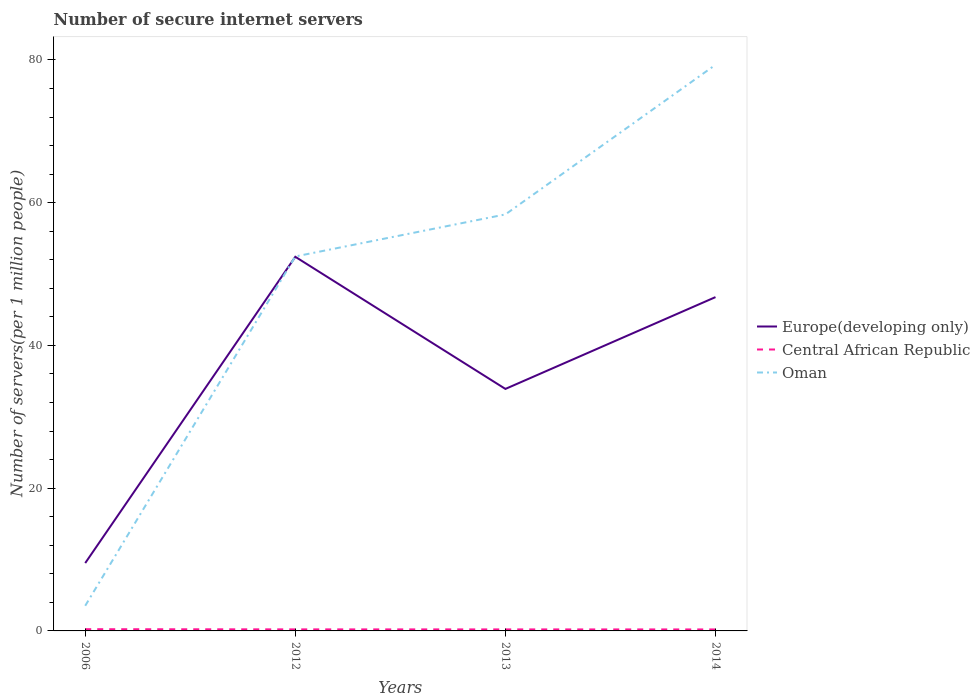How many different coloured lines are there?
Ensure brevity in your answer.  3. Across all years, what is the maximum number of secure internet servers in Central African Republic?
Offer a terse response. 0.21. What is the total number of secure internet servers in Central African Republic in the graph?
Keep it short and to the point. 0. What is the difference between the highest and the second highest number of secure internet servers in Europe(developing only)?
Your response must be concise. 42.91. What is the difference between the highest and the lowest number of secure internet servers in Europe(developing only)?
Keep it short and to the point. 2. Is the number of secure internet servers in Central African Republic strictly greater than the number of secure internet servers in Oman over the years?
Make the answer very short. Yes. How many lines are there?
Keep it short and to the point. 3. What is the difference between two consecutive major ticks on the Y-axis?
Ensure brevity in your answer.  20. Does the graph contain grids?
Make the answer very short. No. How many legend labels are there?
Offer a very short reply. 3. How are the legend labels stacked?
Keep it short and to the point. Vertical. What is the title of the graph?
Give a very brief answer. Number of secure internet servers. What is the label or title of the X-axis?
Offer a terse response. Years. What is the label or title of the Y-axis?
Your answer should be compact. Number of servers(per 1 million people). What is the Number of servers(per 1 million people) in Europe(developing only) in 2006?
Give a very brief answer. 9.51. What is the Number of servers(per 1 million people) of Central African Republic in 2006?
Provide a succinct answer. 0.24. What is the Number of servers(per 1 million people) in Oman in 2006?
Offer a very short reply. 3.52. What is the Number of servers(per 1 million people) in Europe(developing only) in 2012?
Keep it short and to the point. 52.42. What is the Number of servers(per 1 million people) in Central African Republic in 2012?
Offer a very short reply. 0.22. What is the Number of servers(per 1 million people) of Oman in 2012?
Your response must be concise. 52.47. What is the Number of servers(per 1 million people) of Europe(developing only) in 2013?
Offer a very short reply. 33.91. What is the Number of servers(per 1 million people) in Central African Republic in 2013?
Keep it short and to the point. 0.21. What is the Number of servers(per 1 million people) in Oman in 2013?
Keep it short and to the point. 58.36. What is the Number of servers(per 1 million people) in Europe(developing only) in 2014?
Offer a terse response. 46.77. What is the Number of servers(per 1 million people) of Central African Republic in 2014?
Your response must be concise. 0.21. What is the Number of servers(per 1 million people) of Oman in 2014?
Provide a short and direct response. 79.32. Across all years, what is the maximum Number of servers(per 1 million people) of Europe(developing only)?
Ensure brevity in your answer.  52.42. Across all years, what is the maximum Number of servers(per 1 million people) of Central African Republic?
Give a very brief answer. 0.24. Across all years, what is the maximum Number of servers(per 1 million people) of Oman?
Give a very brief answer. 79.32. Across all years, what is the minimum Number of servers(per 1 million people) of Europe(developing only)?
Offer a very short reply. 9.51. Across all years, what is the minimum Number of servers(per 1 million people) of Central African Republic?
Offer a terse response. 0.21. Across all years, what is the minimum Number of servers(per 1 million people) in Oman?
Make the answer very short. 3.52. What is the total Number of servers(per 1 million people) in Europe(developing only) in the graph?
Provide a short and direct response. 142.6. What is the total Number of servers(per 1 million people) in Central African Republic in the graph?
Offer a terse response. 0.88. What is the total Number of servers(per 1 million people) in Oman in the graph?
Make the answer very short. 193.67. What is the difference between the Number of servers(per 1 million people) of Europe(developing only) in 2006 and that in 2012?
Your answer should be very brief. -42.91. What is the difference between the Number of servers(per 1 million people) of Central African Republic in 2006 and that in 2012?
Offer a terse response. 0.03. What is the difference between the Number of servers(per 1 million people) in Oman in 2006 and that in 2012?
Offer a very short reply. -48.94. What is the difference between the Number of servers(per 1 million people) of Europe(developing only) in 2006 and that in 2013?
Your answer should be very brief. -24.4. What is the difference between the Number of servers(per 1 million people) in Oman in 2006 and that in 2013?
Give a very brief answer. -54.83. What is the difference between the Number of servers(per 1 million people) in Europe(developing only) in 2006 and that in 2014?
Provide a succinct answer. -37.26. What is the difference between the Number of servers(per 1 million people) in Central African Republic in 2006 and that in 2014?
Offer a terse response. 0.03. What is the difference between the Number of servers(per 1 million people) in Oman in 2006 and that in 2014?
Offer a very short reply. -75.79. What is the difference between the Number of servers(per 1 million people) of Europe(developing only) in 2012 and that in 2013?
Keep it short and to the point. 18.51. What is the difference between the Number of servers(per 1 million people) in Central African Republic in 2012 and that in 2013?
Keep it short and to the point. 0. What is the difference between the Number of servers(per 1 million people) of Oman in 2012 and that in 2013?
Provide a short and direct response. -5.89. What is the difference between the Number of servers(per 1 million people) of Europe(developing only) in 2012 and that in 2014?
Offer a very short reply. 5.65. What is the difference between the Number of servers(per 1 million people) in Central African Republic in 2012 and that in 2014?
Give a very brief answer. 0.01. What is the difference between the Number of servers(per 1 million people) of Oman in 2012 and that in 2014?
Offer a terse response. -26.85. What is the difference between the Number of servers(per 1 million people) of Europe(developing only) in 2013 and that in 2014?
Your response must be concise. -12.86. What is the difference between the Number of servers(per 1 million people) in Central African Republic in 2013 and that in 2014?
Ensure brevity in your answer.  0. What is the difference between the Number of servers(per 1 million people) in Oman in 2013 and that in 2014?
Ensure brevity in your answer.  -20.96. What is the difference between the Number of servers(per 1 million people) of Europe(developing only) in 2006 and the Number of servers(per 1 million people) of Central African Republic in 2012?
Ensure brevity in your answer.  9.29. What is the difference between the Number of servers(per 1 million people) of Europe(developing only) in 2006 and the Number of servers(per 1 million people) of Oman in 2012?
Your answer should be very brief. -42.96. What is the difference between the Number of servers(per 1 million people) of Central African Republic in 2006 and the Number of servers(per 1 million people) of Oman in 2012?
Make the answer very short. -52.22. What is the difference between the Number of servers(per 1 million people) of Europe(developing only) in 2006 and the Number of servers(per 1 million people) of Central African Republic in 2013?
Your answer should be compact. 9.3. What is the difference between the Number of servers(per 1 million people) in Europe(developing only) in 2006 and the Number of servers(per 1 million people) in Oman in 2013?
Ensure brevity in your answer.  -48.85. What is the difference between the Number of servers(per 1 million people) in Central African Republic in 2006 and the Number of servers(per 1 million people) in Oman in 2013?
Offer a terse response. -58.12. What is the difference between the Number of servers(per 1 million people) in Europe(developing only) in 2006 and the Number of servers(per 1 million people) in Central African Republic in 2014?
Give a very brief answer. 9.3. What is the difference between the Number of servers(per 1 million people) of Europe(developing only) in 2006 and the Number of servers(per 1 million people) of Oman in 2014?
Ensure brevity in your answer.  -69.81. What is the difference between the Number of servers(per 1 million people) of Central African Republic in 2006 and the Number of servers(per 1 million people) of Oman in 2014?
Offer a terse response. -79.08. What is the difference between the Number of servers(per 1 million people) of Europe(developing only) in 2012 and the Number of servers(per 1 million people) of Central African Republic in 2013?
Provide a succinct answer. 52.21. What is the difference between the Number of servers(per 1 million people) in Europe(developing only) in 2012 and the Number of servers(per 1 million people) in Oman in 2013?
Your answer should be very brief. -5.94. What is the difference between the Number of servers(per 1 million people) of Central African Republic in 2012 and the Number of servers(per 1 million people) of Oman in 2013?
Ensure brevity in your answer.  -58.14. What is the difference between the Number of servers(per 1 million people) of Europe(developing only) in 2012 and the Number of servers(per 1 million people) of Central African Republic in 2014?
Provide a succinct answer. 52.21. What is the difference between the Number of servers(per 1 million people) in Europe(developing only) in 2012 and the Number of servers(per 1 million people) in Oman in 2014?
Keep it short and to the point. -26.9. What is the difference between the Number of servers(per 1 million people) of Central African Republic in 2012 and the Number of servers(per 1 million people) of Oman in 2014?
Give a very brief answer. -79.1. What is the difference between the Number of servers(per 1 million people) of Europe(developing only) in 2013 and the Number of servers(per 1 million people) of Central African Republic in 2014?
Keep it short and to the point. 33.7. What is the difference between the Number of servers(per 1 million people) in Europe(developing only) in 2013 and the Number of servers(per 1 million people) in Oman in 2014?
Your response must be concise. -45.41. What is the difference between the Number of servers(per 1 million people) in Central African Republic in 2013 and the Number of servers(per 1 million people) in Oman in 2014?
Offer a very short reply. -79.11. What is the average Number of servers(per 1 million people) in Europe(developing only) per year?
Provide a short and direct response. 35.65. What is the average Number of servers(per 1 million people) in Central African Republic per year?
Make the answer very short. 0.22. What is the average Number of servers(per 1 million people) of Oman per year?
Your answer should be very brief. 48.42. In the year 2006, what is the difference between the Number of servers(per 1 million people) in Europe(developing only) and Number of servers(per 1 million people) in Central African Republic?
Your answer should be compact. 9.27. In the year 2006, what is the difference between the Number of servers(per 1 million people) of Europe(developing only) and Number of servers(per 1 million people) of Oman?
Make the answer very short. 5.98. In the year 2006, what is the difference between the Number of servers(per 1 million people) in Central African Republic and Number of servers(per 1 million people) in Oman?
Offer a terse response. -3.28. In the year 2012, what is the difference between the Number of servers(per 1 million people) of Europe(developing only) and Number of servers(per 1 million people) of Central African Republic?
Your answer should be compact. 52.2. In the year 2012, what is the difference between the Number of servers(per 1 million people) of Europe(developing only) and Number of servers(per 1 million people) of Oman?
Keep it short and to the point. -0.05. In the year 2012, what is the difference between the Number of servers(per 1 million people) in Central African Republic and Number of servers(per 1 million people) in Oman?
Your response must be concise. -52.25. In the year 2013, what is the difference between the Number of servers(per 1 million people) of Europe(developing only) and Number of servers(per 1 million people) of Central African Republic?
Give a very brief answer. 33.69. In the year 2013, what is the difference between the Number of servers(per 1 million people) of Europe(developing only) and Number of servers(per 1 million people) of Oman?
Your response must be concise. -24.45. In the year 2013, what is the difference between the Number of servers(per 1 million people) in Central African Republic and Number of servers(per 1 million people) in Oman?
Your answer should be compact. -58.15. In the year 2014, what is the difference between the Number of servers(per 1 million people) in Europe(developing only) and Number of servers(per 1 million people) in Central African Republic?
Your answer should be compact. 46.56. In the year 2014, what is the difference between the Number of servers(per 1 million people) of Europe(developing only) and Number of servers(per 1 million people) of Oman?
Provide a short and direct response. -32.55. In the year 2014, what is the difference between the Number of servers(per 1 million people) of Central African Republic and Number of servers(per 1 million people) of Oman?
Your answer should be very brief. -79.11. What is the ratio of the Number of servers(per 1 million people) in Europe(developing only) in 2006 to that in 2012?
Offer a terse response. 0.18. What is the ratio of the Number of servers(per 1 million people) in Central African Republic in 2006 to that in 2012?
Ensure brevity in your answer.  1.12. What is the ratio of the Number of servers(per 1 million people) in Oman in 2006 to that in 2012?
Provide a short and direct response. 0.07. What is the ratio of the Number of servers(per 1 million people) of Europe(developing only) in 2006 to that in 2013?
Make the answer very short. 0.28. What is the ratio of the Number of servers(per 1 million people) of Central African Republic in 2006 to that in 2013?
Provide a succinct answer. 1.14. What is the ratio of the Number of servers(per 1 million people) of Oman in 2006 to that in 2013?
Your answer should be very brief. 0.06. What is the ratio of the Number of servers(per 1 million people) of Europe(developing only) in 2006 to that in 2014?
Keep it short and to the point. 0.2. What is the ratio of the Number of servers(per 1 million people) of Central African Republic in 2006 to that in 2014?
Your response must be concise. 1.16. What is the ratio of the Number of servers(per 1 million people) in Oman in 2006 to that in 2014?
Provide a short and direct response. 0.04. What is the ratio of the Number of servers(per 1 million people) of Europe(developing only) in 2012 to that in 2013?
Your answer should be compact. 1.55. What is the ratio of the Number of servers(per 1 million people) in Central African Republic in 2012 to that in 2013?
Your response must be concise. 1.02. What is the ratio of the Number of servers(per 1 million people) of Oman in 2012 to that in 2013?
Your answer should be compact. 0.9. What is the ratio of the Number of servers(per 1 million people) in Europe(developing only) in 2012 to that in 2014?
Your answer should be compact. 1.12. What is the ratio of the Number of servers(per 1 million people) in Oman in 2012 to that in 2014?
Keep it short and to the point. 0.66. What is the ratio of the Number of servers(per 1 million people) of Europe(developing only) in 2013 to that in 2014?
Provide a succinct answer. 0.72. What is the ratio of the Number of servers(per 1 million people) in Central African Republic in 2013 to that in 2014?
Provide a succinct answer. 1.02. What is the ratio of the Number of servers(per 1 million people) of Oman in 2013 to that in 2014?
Your answer should be compact. 0.74. What is the difference between the highest and the second highest Number of servers(per 1 million people) in Europe(developing only)?
Your answer should be very brief. 5.65. What is the difference between the highest and the second highest Number of servers(per 1 million people) in Central African Republic?
Offer a very short reply. 0.03. What is the difference between the highest and the second highest Number of servers(per 1 million people) in Oman?
Keep it short and to the point. 20.96. What is the difference between the highest and the lowest Number of servers(per 1 million people) in Europe(developing only)?
Your answer should be compact. 42.91. What is the difference between the highest and the lowest Number of servers(per 1 million people) of Central African Republic?
Your response must be concise. 0.03. What is the difference between the highest and the lowest Number of servers(per 1 million people) of Oman?
Your response must be concise. 75.79. 